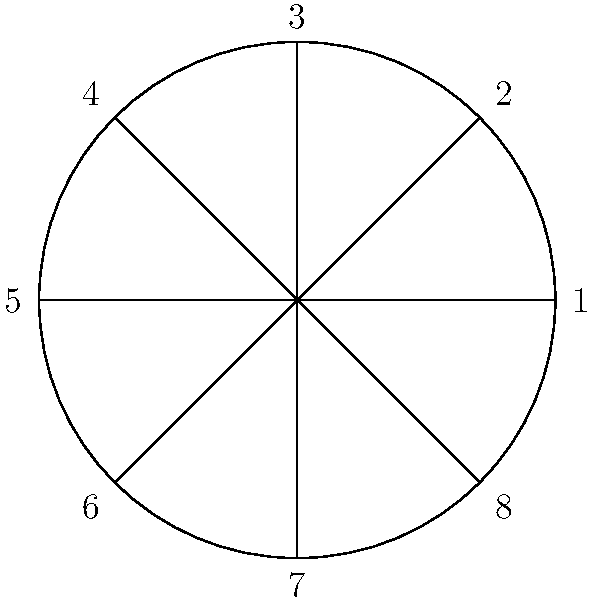You've ordered a large pizza to help you cope with your work stress. The pizza is cut into 8 equal slices, as shown in the diagram. Let's consider the dihedral group $D_8$ of symmetries of this octagon-shaped pizza. If you apply a rotation of 45° clockwise followed by a reflection across the vertical axis, which slice will end up in the position originally occupied by slice 1? Let's approach this step-by-step:

1) First, we need to understand the group elements:
   - Rotations are denoted as $r_k$ where $k$ is the number of 45° clockwise rotations.
   - Reflections are denoted as $s_k$ where $k$ is the number of the axis of reflection (1-8).

2) The operation described is a composition of two actions:
   - A 45° clockwise rotation (r_1)
   - A reflection across the vertical axis (s_3)

3) In group theory, we apply these operations from right to left. So we'll do $s_3 \circ r_1$

4) Let's follow the position of slice 1:
   - After $r_1$ (45° clockwise rotation): 1 moves to 8
   - Then $s_3$ (reflection across vertical axis): 8 reflects to 4

5) Therefore, after these operations, the slice that ends up in the position originally occupied by slice 1 is slice 4.

This problem demonstrates the non-commutative nature of the dihedral group, as $s_3 \circ r_1 \neq r_1 \circ s_3$.
Answer: 4 